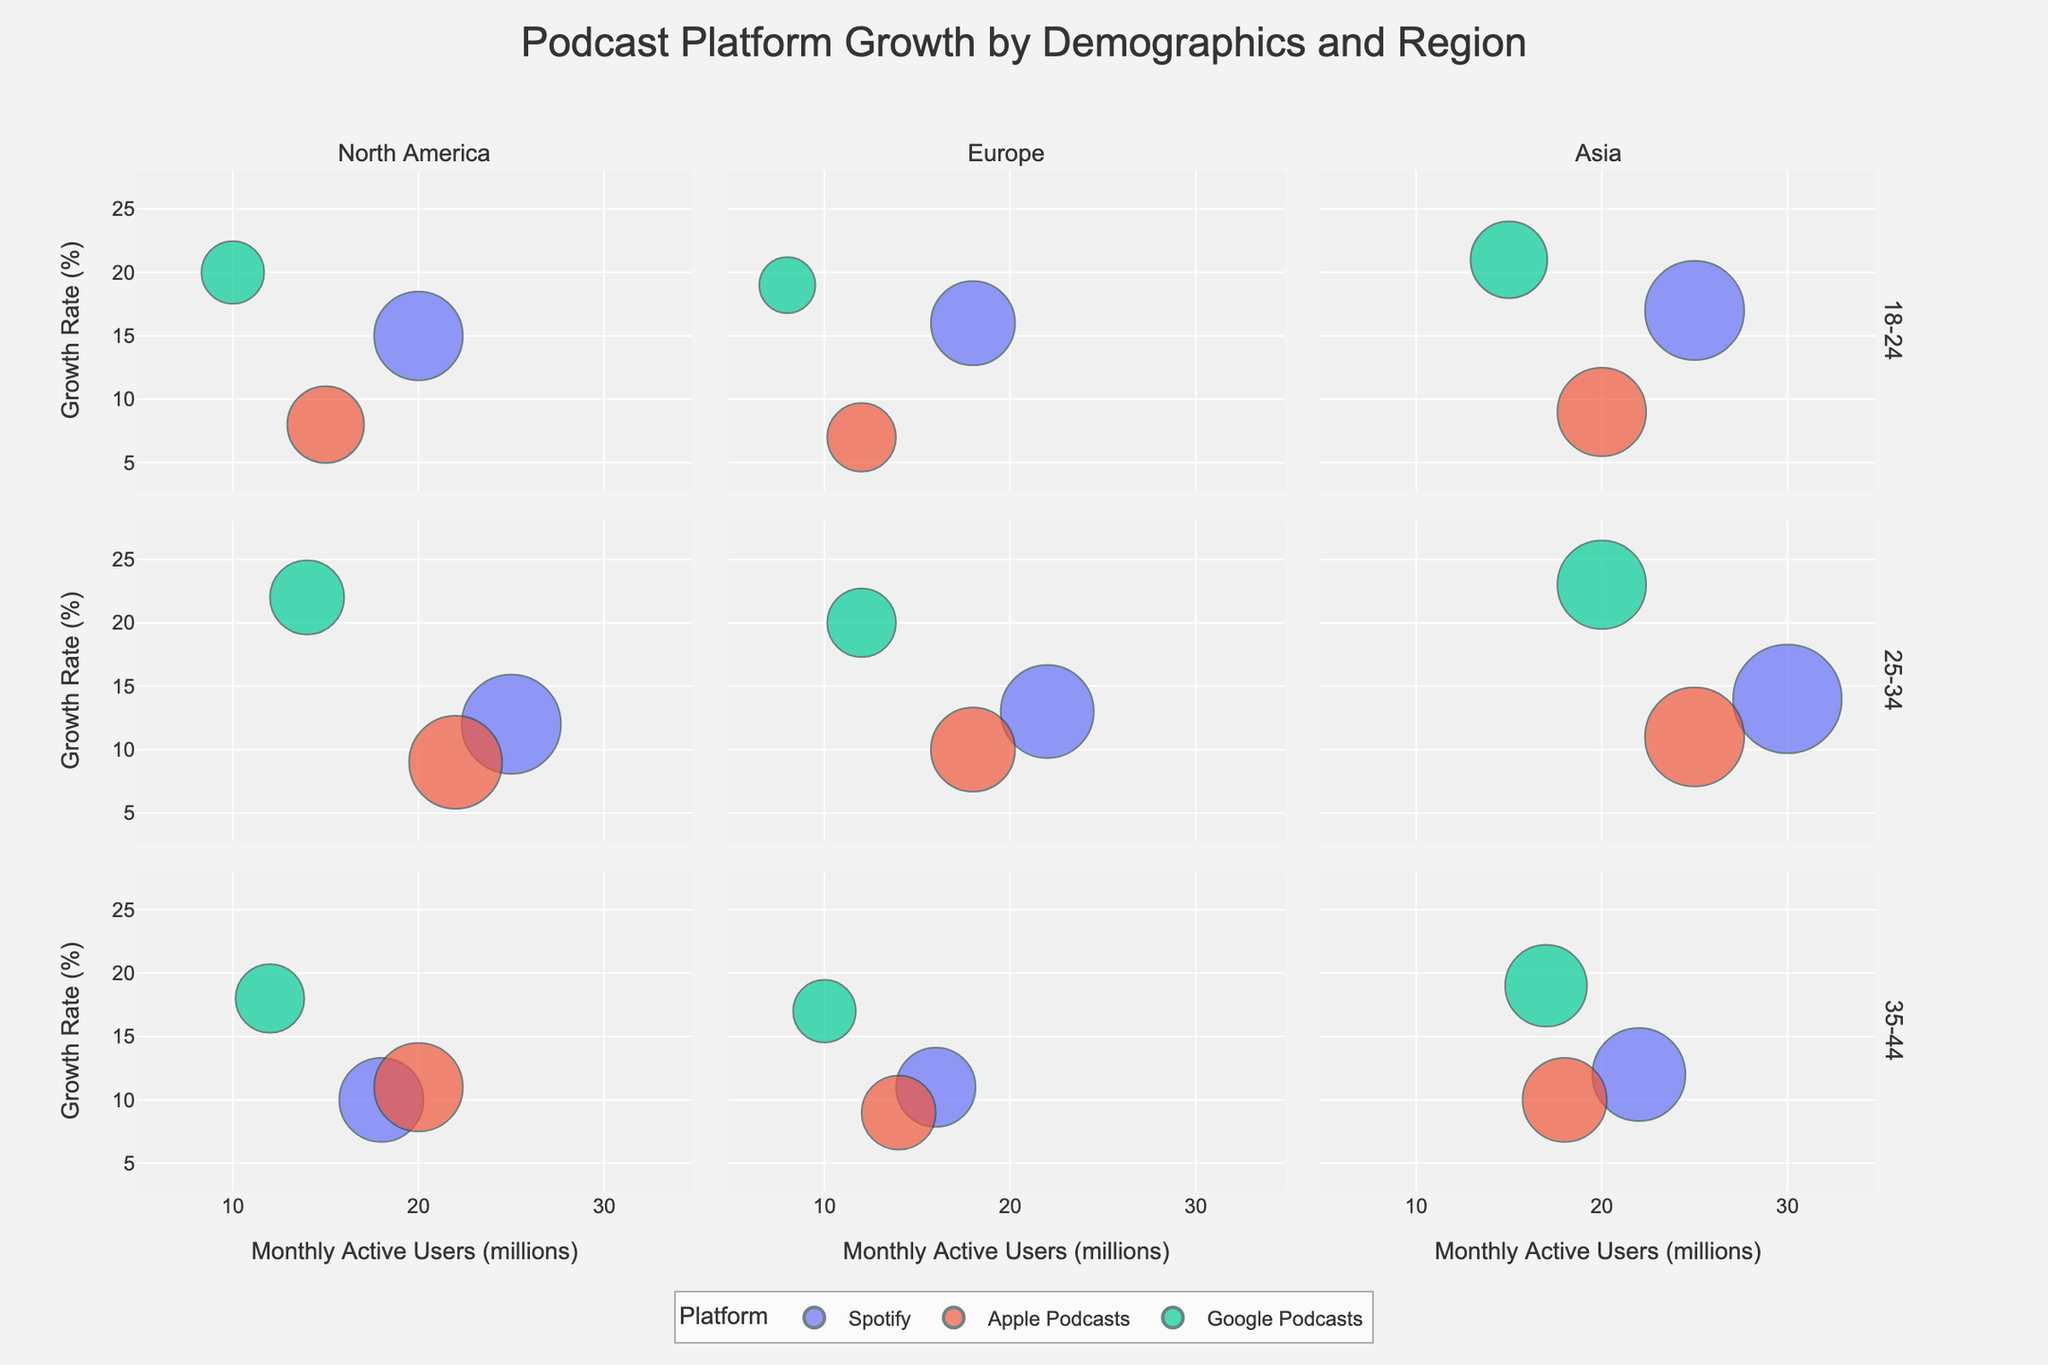What's the title of the chart? The title is always located at the top of the figure. It helps in understanding the overall topic of the chart. In this case, the title is "Podcast Platform Growth by Demographics and Region" as given in the code.
Answer: Podcast Platform Growth by Demographics and Region What are the axes labels? The axes labels are visible on both the x-axis and y-axis of the figure. The x-axis label is "Monthly Active Users (millions)", and the y-axis label is "Growth Rate (%)". These labels provide context for the data points plotted in the chart.
Answer: Monthly Active Users (millions) and Growth Rate (%) Which platform shows the highest growth rate in Asia for the 18-24 age group? Look at the Asia region and the 18-24 age group facet to find the bubble with the highest position on the y-axis (Growth Rate). For the 18-24 age group in Asia, Google Podcasts has the highest bubble, indicating the highest growth rate.
Answer: Google Podcasts What is the total number of data points shown in the figure? To find the total number of data points, count the number of bubbles in the entire chart. Since the chart is faceted by region and age group and each demographic has multiple platforms, summing the individual data points across all facets gives the total.
Answer: 27 Which platform has the largest bubble in Europe for the 25-34 age group? Locate the facet for Europe and the 25-34 age group. Identify which bubble is visually the largest (representing the highest number of Monthly Active Users). In this case, Spotify has the largest bubble.
Answer: Spotify Which region shows the overall highest growth rate for users aged 25-34? Compare the bubbles across different regions (North America, Europe, Asia) for the 25-34 age group. The region with the highest position bubbles on the y-axis indicates the highest overall growth rate. Asia has the highest growth rates in the 25-34 age group.
Answer: Asia What is the average growth rate of Google Podcasts across all regions for the 35-44 age group? Locate all the bubbles for Google Podcasts in the 35-44 age group across all regions. Add the growth rates (18% from North America, 17% from Europe, 19% from Asia) and divide by the number of regions (3). (18 + 17 + 19) / 3 = 54 / 3 = 18%.
Answer: 18% Which podcasting platform targets the youngest age group more aggressively in terms of growth rate in North America? Look at the North America region and the 18-24 age group facet. Compare the growth rates of all platforms. Google Podcasts has the highest growth rate, indicating aggressive targeting.
Answer: Google Podcasts How does the growth rate of Spotify in North America for the 18-24 age group compare to its growth rate in Europe for the same age group? Compare the positions of Spotify's bubbles in North America and Europe within the 18-24 age group. North America's growth rate for Spotify is 15% and Europe's is 16%. Europe has a slightly higher growth rate.
Answer: Europe is slightly higher at 16% compared to 15% in North America What is the difference in Monthly Active Users between Apple Podcasts and Google Podcasts in Asia for the 25-34 age group? Look at the Asia region and the 25-34 age group facet. Apple Podcasts has 25 million, while Google Podcasts has 20 million Monthly Active Users. The difference is 25 - 20 = 5 million.
Answer: 5 million 